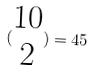<formula> <loc_0><loc_0><loc_500><loc_500>( \begin{matrix} 1 0 \\ 2 \end{matrix} ) = 4 5</formula> 